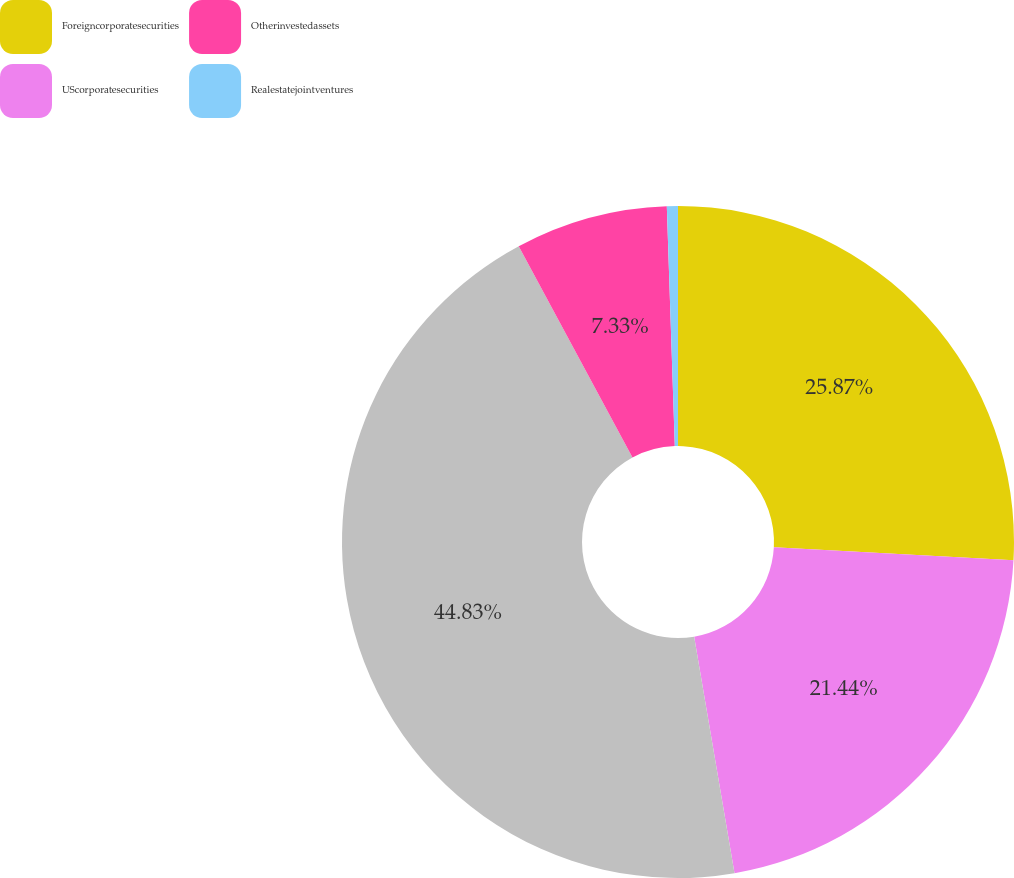<chart> <loc_0><loc_0><loc_500><loc_500><pie_chart><fcel>Foreigncorporatesecurities<fcel>UScorporatesecurities<fcel>Unnamed: 2<fcel>Otherinvestedassets<fcel>Realestatejointventures<nl><fcel>25.87%<fcel>21.44%<fcel>44.83%<fcel>7.33%<fcel>0.53%<nl></chart> 